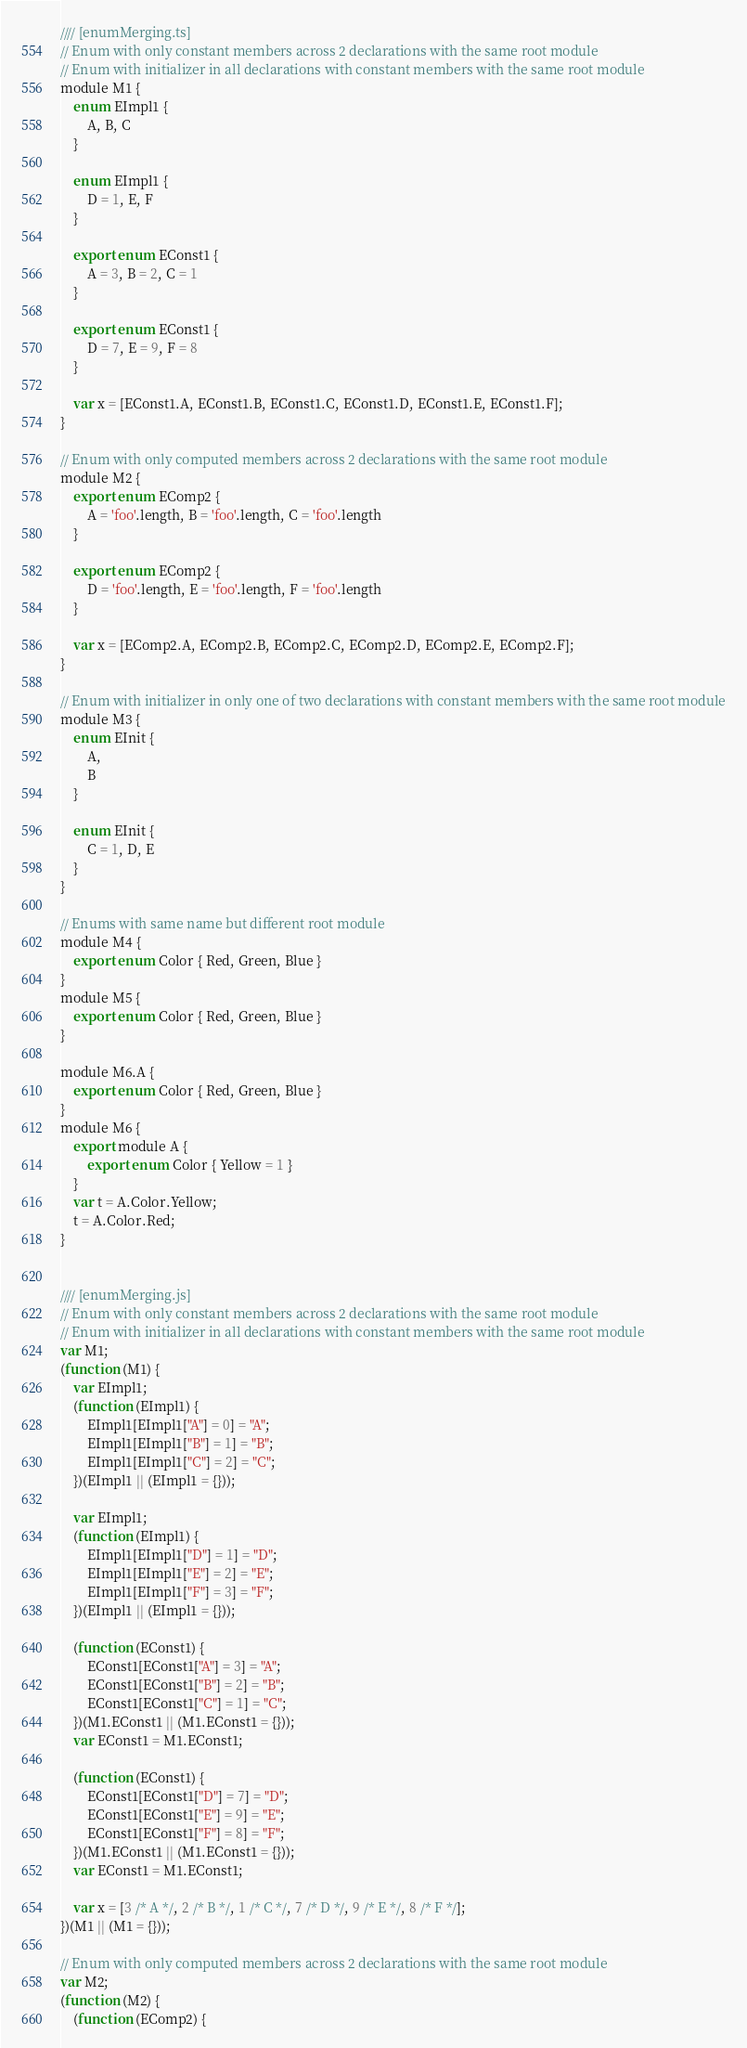Convert code to text. <code><loc_0><loc_0><loc_500><loc_500><_JavaScript_>//// [enumMerging.ts]
// Enum with only constant members across 2 declarations with the same root module
// Enum with initializer in all declarations with constant members with the same root module
module M1 {
    enum EImpl1 {
        A, B, C
    }

    enum EImpl1 {
        D = 1, E, F
    }

    export enum EConst1 {
        A = 3, B = 2, C = 1
    }

    export enum EConst1 {
        D = 7, E = 9, F = 8
    }

    var x = [EConst1.A, EConst1.B, EConst1.C, EConst1.D, EConst1.E, EConst1.F];
}

// Enum with only computed members across 2 declarations with the same root module 
module M2 {
    export enum EComp2 {
        A = 'foo'.length, B = 'foo'.length, C = 'foo'.length
    }

    export enum EComp2 {
        D = 'foo'.length, E = 'foo'.length, F = 'foo'.length
    }

    var x = [EComp2.A, EComp2.B, EComp2.C, EComp2.D, EComp2.E, EComp2.F];
}

// Enum with initializer in only one of two declarations with constant members with the same root module
module M3 {
    enum EInit {
        A,
        B
    }

    enum EInit {
        C = 1, D, E
    }
}

// Enums with same name but different root module
module M4 {
    export enum Color { Red, Green, Blue }
}
module M5 {
    export enum Color { Red, Green, Blue }
}

module M6.A {
    export enum Color { Red, Green, Blue }
}
module M6 {
    export module A {
        export enum Color { Yellow = 1 }
    }
    var t = A.Color.Yellow;
    t = A.Color.Red;
}


//// [enumMerging.js]
// Enum with only constant members across 2 declarations with the same root module
// Enum with initializer in all declarations with constant members with the same root module
var M1;
(function (M1) {
    var EImpl1;
    (function (EImpl1) {
        EImpl1[EImpl1["A"] = 0] = "A";
        EImpl1[EImpl1["B"] = 1] = "B";
        EImpl1[EImpl1["C"] = 2] = "C";
    })(EImpl1 || (EImpl1 = {}));

    var EImpl1;
    (function (EImpl1) {
        EImpl1[EImpl1["D"] = 1] = "D";
        EImpl1[EImpl1["E"] = 2] = "E";
        EImpl1[EImpl1["F"] = 3] = "F";
    })(EImpl1 || (EImpl1 = {}));

    (function (EConst1) {
        EConst1[EConst1["A"] = 3] = "A";
        EConst1[EConst1["B"] = 2] = "B";
        EConst1[EConst1["C"] = 1] = "C";
    })(M1.EConst1 || (M1.EConst1 = {}));
    var EConst1 = M1.EConst1;

    (function (EConst1) {
        EConst1[EConst1["D"] = 7] = "D";
        EConst1[EConst1["E"] = 9] = "E";
        EConst1[EConst1["F"] = 8] = "F";
    })(M1.EConst1 || (M1.EConst1 = {}));
    var EConst1 = M1.EConst1;

    var x = [3 /* A */, 2 /* B */, 1 /* C */, 7 /* D */, 9 /* E */, 8 /* F */];
})(M1 || (M1 = {}));

// Enum with only computed members across 2 declarations with the same root module
var M2;
(function (M2) {
    (function (EComp2) {</code> 